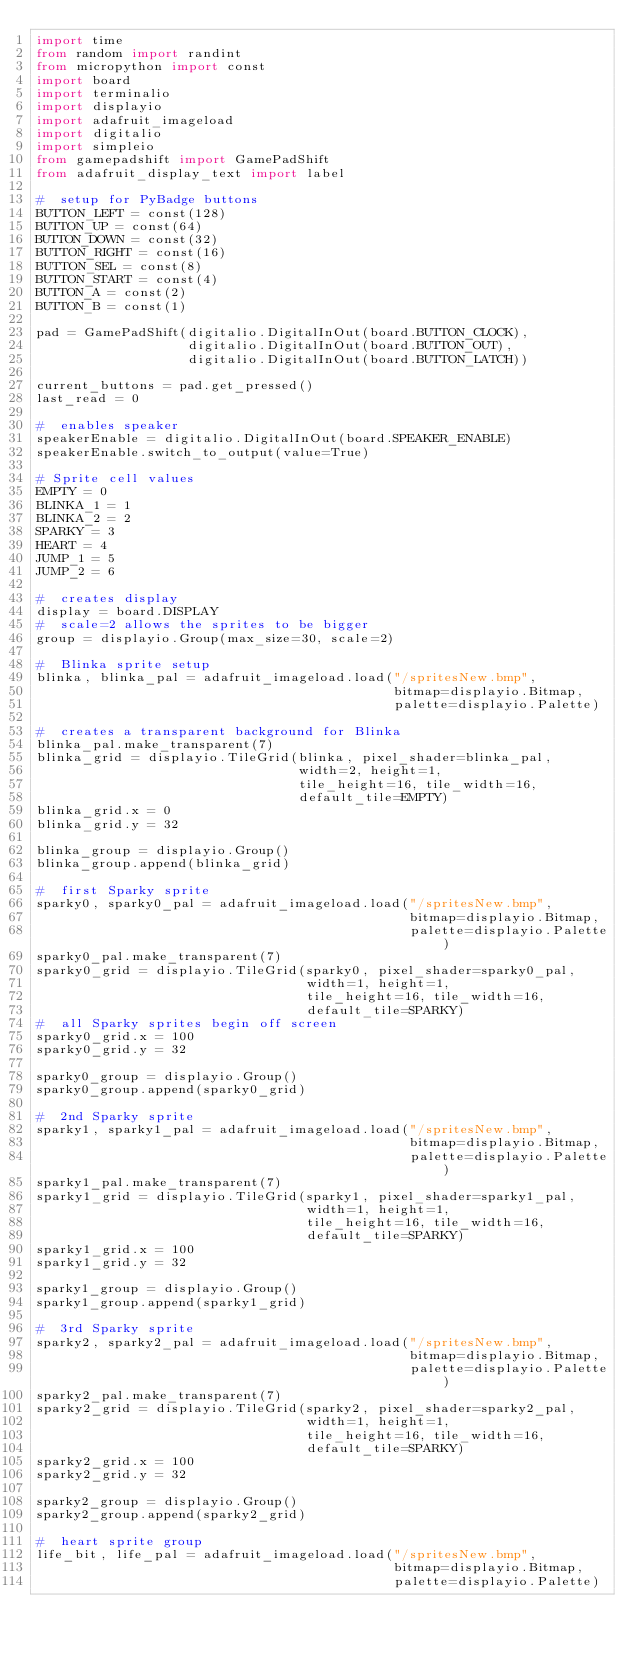Convert code to text. <code><loc_0><loc_0><loc_500><loc_500><_Python_>import time
from random import randint
from micropython import const
import board
import terminalio
import displayio
import adafruit_imageload
import digitalio
import simpleio
from gamepadshift import GamePadShift
from adafruit_display_text import label

#  setup for PyBadge buttons
BUTTON_LEFT = const(128)
BUTTON_UP = const(64)
BUTTON_DOWN = const(32)
BUTTON_RIGHT = const(16)
BUTTON_SEL = const(8)
BUTTON_START = const(4)
BUTTON_A = const(2)
BUTTON_B = const(1)

pad = GamePadShift(digitalio.DigitalInOut(board.BUTTON_CLOCK),
                   digitalio.DigitalInOut(board.BUTTON_OUT),
                   digitalio.DigitalInOut(board.BUTTON_LATCH))

current_buttons = pad.get_pressed()
last_read = 0

#  enables speaker
speakerEnable = digitalio.DigitalInOut(board.SPEAKER_ENABLE)
speakerEnable.switch_to_output(value=True)

# Sprite cell values
EMPTY = 0
BLINKA_1 = 1
BLINKA_2 = 2
SPARKY = 3
HEART = 4
JUMP_1 = 5
JUMP_2 = 6

#  creates display
display = board.DISPLAY
#  scale=2 allows the sprites to be bigger
group = displayio.Group(max_size=30, scale=2)

#  Blinka sprite setup
blinka, blinka_pal = adafruit_imageload.load("/spritesNew.bmp",
                                             bitmap=displayio.Bitmap,
                                             palette=displayio.Palette)

#  creates a transparent background for Blinka
blinka_pal.make_transparent(7)
blinka_grid = displayio.TileGrid(blinka, pixel_shader=blinka_pal,
                                 width=2, height=1,
                                 tile_height=16, tile_width=16,
                                 default_tile=EMPTY)
blinka_grid.x = 0
blinka_grid.y = 32

blinka_group = displayio.Group()
blinka_group.append(blinka_grid)

#  first Sparky sprite
sparky0, sparky0_pal = adafruit_imageload.load("/spritesNew.bmp",
                                               bitmap=displayio.Bitmap,
                                               palette=displayio.Palette)
sparky0_pal.make_transparent(7)
sparky0_grid = displayio.TileGrid(sparky0, pixel_shader=sparky0_pal,
                                  width=1, height=1,
                                  tile_height=16, tile_width=16,
                                  default_tile=SPARKY)
#  all Sparky sprites begin off screen
sparky0_grid.x = 100
sparky0_grid.y = 32

sparky0_group = displayio.Group()
sparky0_group.append(sparky0_grid)

#  2nd Sparky sprite
sparky1, sparky1_pal = adafruit_imageload.load("/spritesNew.bmp",
                                               bitmap=displayio.Bitmap,
                                               palette=displayio.Palette)
sparky1_pal.make_transparent(7)
sparky1_grid = displayio.TileGrid(sparky1, pixel_shader=sparky1_pal,
                                  width=1, height=1,
                                  tile_height=16, tile_width=16,
                                  default_tile=SPARKY)
sparky1_grid.x = 100
sparky1_grid.y = 32

sparky1_group = displayio.Group()
sparky1_group.append(sparky1_grid)

#  3rd Sparky sprite
sparky2, sparky2_pal = adafruit_imageload.load("/spritesNew.bmp",
                                               bitmap=displayio.Bitmap,
                                               palette=displayio.Palette)
sparky2_pal.make_transparent(7)
sparky2_grid = displayio.TileGrid(sparky2, pixel_shader=sparky2_pal,
                                  width=1, height=1,
                                  tile_height=16, tile_width=16,
                                  default_tile=SPARKY)
sparky2_grid.x = 100
sparky2_grid.y = 32

sparky2_group = displayio.Group()
sparky2_group.append(sparky2_grid)

#  heart sprite group
life_bit, life_pal = adafruit_imageload.load("/spritesNew.bmp",
                                             bitmap=displayio.Bitmap,
                                             palette=displayio.Palette)</code> 